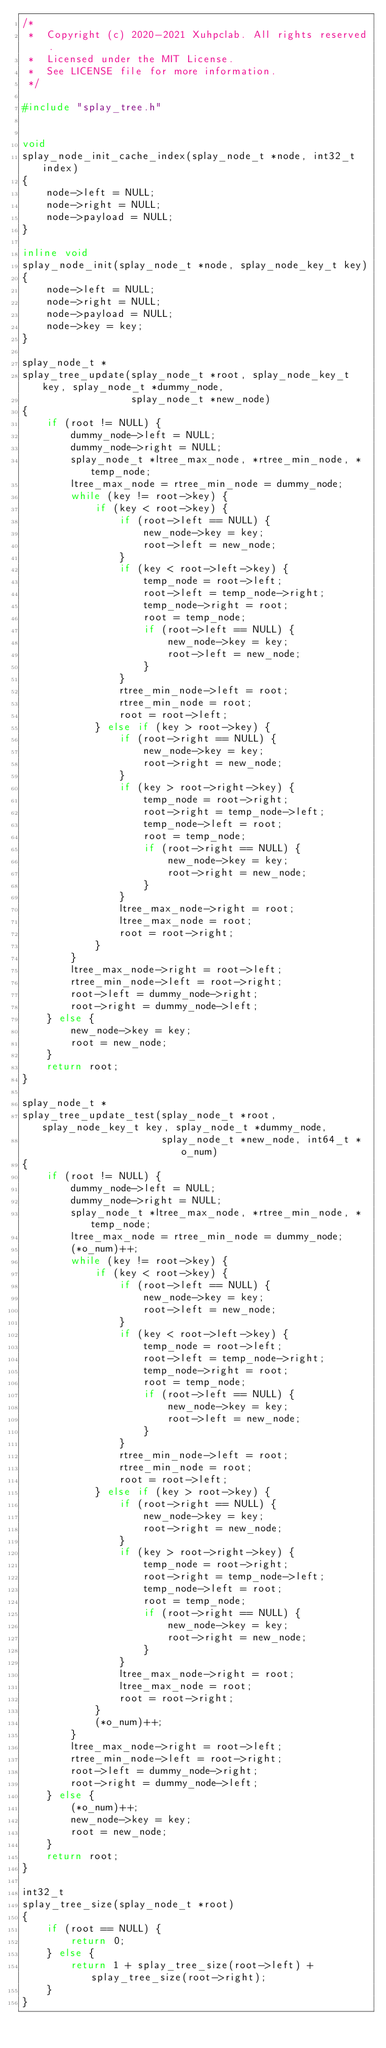Convert code to text. <code><loc_0><loc_0><loc_500><loc_500><_C++_>/* 
 *  Copyright (c) 2020-2021 Xuhpclab. All rights reserved.
 *  Licensed under the MIT License.
 *  See LICENSE file for more information.
 */

#include "splay_tree.h"


void
splay_node_init_cache_index(splay_node_t *node, int32_t index)
{
    node->left = NULL;
    node->right = NULL;
    node->payload = NULL;
}

inline void
splay_node_init(splay_node_t *node, splay_node_key_t key)
{
    node->left = NULL;
    node->right = NULL;
    node->payload = NULL;
    node->key = key;
}

splay_node_t *
splay_tree_update(splay_node_t *root, splay_node_key_t key, splay_node_t *dummy_node,
                  splay_node_t *new_node)
{
    if (root != NULL) {
        dummy_node->left = NULL;
        dummy_node->right = NULL;
        splay_node_t *ltree_max_node, *rtree_min_node, *temp_node;
        ltree_max_node = rtree_min_node = dummy_node;
        while (key != root->key) {
            if (key < root->key) {
                if (root->left == NULL) {
                    new_node->key = key;
                    root->left = new_node;
                }
                if (key < root->left->key) {
                    temp_node = root->left;
                    root->left = temp_node->right;
                    temp_node->right = root;
                    root = temp_node;
                    if (root->left == NULL) {
                        new_node->key = key;
                        root->left = new_node;
                    }
                }
                rtree_min_node->left = root;
                rtree_min_node = root;
                root = root->left;
            } else if (key > root->key) {
                if (root->right == NULL) {
                    new_node->key = key;
                    root->right = new_node;
                }
                if (key > root->right->key) {
                    temp_node = root->right;
                    root->right = temp_node->left;
                    temp_node->left = root;
                    root = temp_node;
                    if (root->right == NULL) {
                        new_node->key = key;
                        root->right = new_node;
                    }
                }
                ltree_max_node->right = root;
                ltree_max_node = root;
                root = root->right;
            }
        }
        ltree_max_node->right = root->left;
        rtree_min_node->left = root->right;
        root->left = dummy_node->right;
        root->right = dummy_node->left;
    } else {
        new_node->key = key;
        root = new_node;
    }
    return root;
}

splay_node_t *
splay_tree_update_test(splay_node_t *root, splay_node_key_t key, splay_node_t *dummy_node,
                       splay_node_t *new_node, int64_t *o_num)
{
    if (root != NULL) {
        dummy_node->left = NULL;
        dummy_node->right = NULL;
        splay_node_t *ltree_max_node, *rtree_min_node, *temp_node;
        ltree_max_node = rtree_min_node = dummy_node;
        (*o_num)++;
        while (key != root->key) {
            if (key < root->key) {
                if (root->left == NULL) {
                    new_node->key = key;
                    root->left = new_node;
                }
                if (key < root->left->key) {
                    temp_node = root->left;
                    root->left = temp_node->right;
                    temp_node->right = root;
                    root = temp_node;
                    if (root->left == NULL) {
                        new_node->key = key;
                        root->left = new_node;
                    }
                }
                rtree_min_node->left = root;
                rtree_min_node = root;
                root = root->left;
            } else if (key > root->key) {
                if (root->right == NULL) {
                    new_node->key = key;
                    root->right = new_node;
                }
                if (key > root->right->key) {
                    temp_node = root->right;
                    root->right = temp_node->left;
                    temp_node->left = root;
                    root = temp_node;
                    if (root->right == NULL) {
                        new_node->key = key;
                        root->right = new_node;
                    }
                }
                ltree_max_node->right = root;
                ltree_max_node = root;
                root = root->right;
            }
            (*o_num)++;
        }
        ltree_max_node->right = root->left;
        rtree_min_node->left = root->right;
        root->left = dummy_node->right;
        root->right = dummy_node->left;
    } else {
        (*o_num)++;
        new_node->key = key;
        root = new_node;
    }
    return root;
}

int32_t
splay_tree_size(splay_node_t *root)
{
    if (root == NULL) {
        return 0;
    } else {
        return 1 + splay_tree_size(root->left) + splay_tree_size(root->right);
    }
}
</code> 